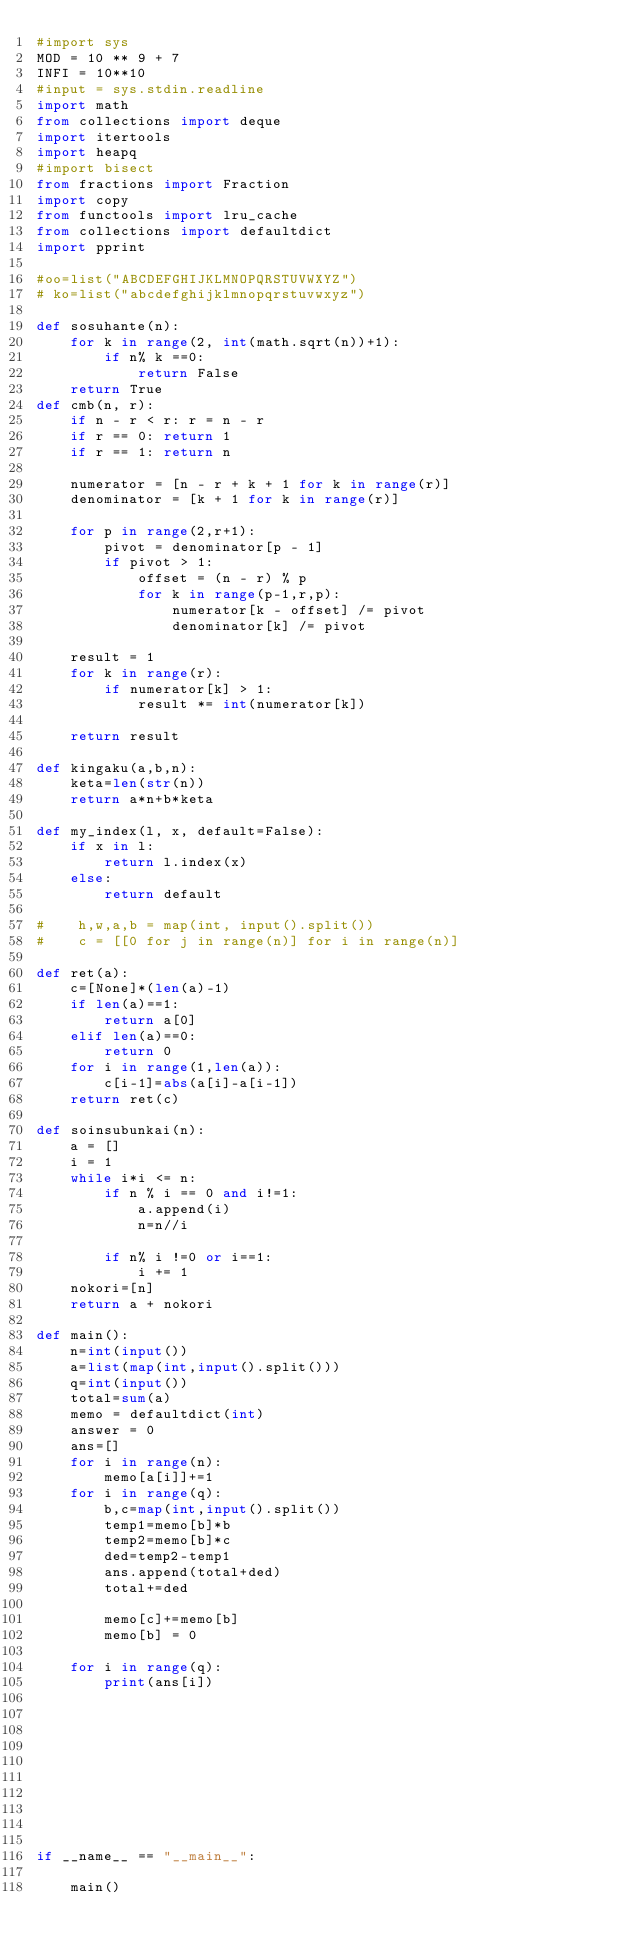<code> <loc_0><loc_0><loc_500><loc_500><_Python_>#import sys
MOD = 10 ** 9 + 7
INFI = 10**10
#input = sys.stdin.readline
import math
from collections import deque
import itertools
import heapq
#import bisect
from fractions import Fraction
import copy
from functools import lru_cache
from collections import defaultdict
import pprint

#oo=list("ABCDEFGHIJKLMNOPQRSTUVWXYZ")
# ko=list("abcdefghijklmnopqrstuvwxyz")

def sosuhante(n):
    for k in range(2, int(math.sqrt(n))+1):
        if n% k ==0:
            return False
    return True
def cmb(n, r):
    if n - r < r: r = n - r
    if r == 0: return 1
    if r == 1: return n

    numerator = [n - r + k + 1 for k in range(r)]
    denominator = [k + 1 for k in range(r)]

    for p in range(2,r+1):
        pivot = denominator[p - 1]
        if pivot > 1:
            offset = (n - r) % p
            for k in range(p-1,r,p):
                numerator[k - offset] /= pivot
                denominator[k] /= pivot

    result = 1
    for k in range(r):
        if numerator[k] > 1:
            result *= int(numerator[k])

    return result

def kingaku(a,b,n):
    keta=len(str(n))
    return a*n+b*keta

def my_index(l, x, default=False):
    if x in l:
        return l.index(x)
    else:
        return default

#    h,w,a,b = map(int, input().split())
#    c = [[0 for j in range(n)] for i in range(n)]

def ret(a):
    c=[None]*(len(a)-1)
    if len(a)==1:
        return a[0]
    elif len(a)==0:
        return 0
    for i in range(1,len(a)):
        c[i-1]=abs(a[i]-a[i-1])
    return ret(c)

def soinsubunkai(n):
    a = []
    i = 1
    while i*i <= n:
        if n % i == 0 and i!=1:
            a.append(i)
            n=n//i

        if n% i !=0 or i==1:
            i += 1
    nokori=[n]
    return a + nokori

def main():
    n=int(input())
    a=list(map(int,input().split()))
    q=int(input())
    total=sum(a)
    memo = defaultdict(int)
    answer = 0
    ans=[]
    for i in range(n):
        memo[a[i]]+=1
    for i in range(q):
        b,c=map(int,input().split())
        temp1=memo[b]*b
        temp2=memo[b]*c
        ded=temp2-temp1
        ans.append(total+ded)
        total+=ded

        memo[c]+=memo[b]
        memo[b] = 0

    for i in range(q):
        print(ans[i])










if __name__ == "__main__":

    main()</code> 